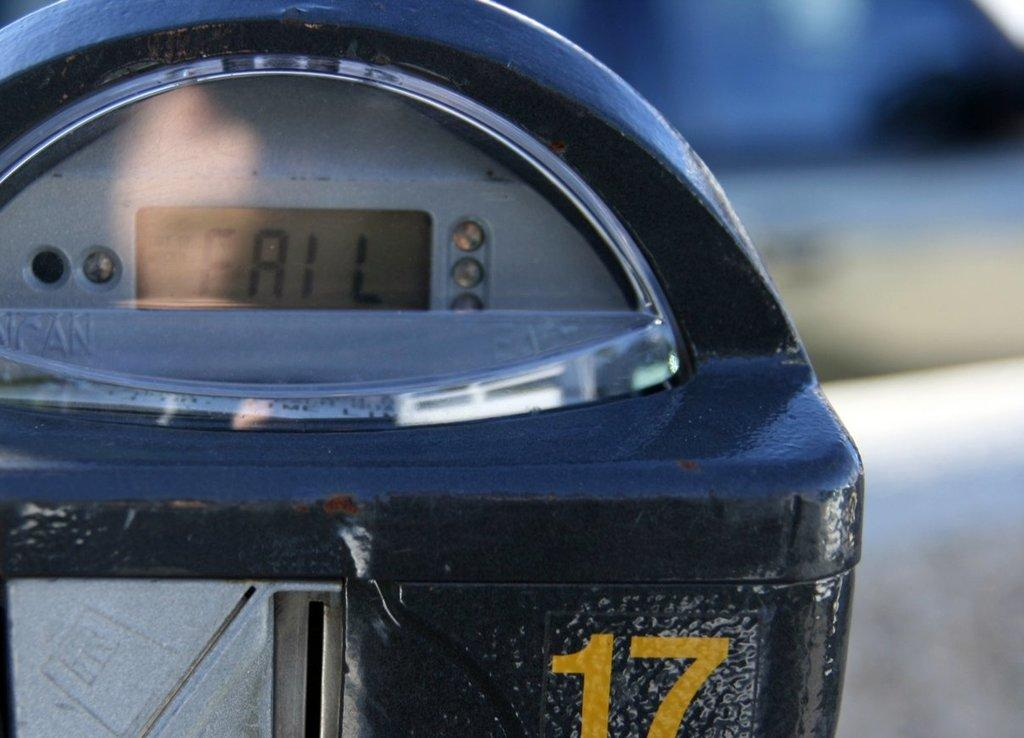<image>
Render a clear and concise summary of the photo. A fail sign has appeared on the parking meter labeled 17. 